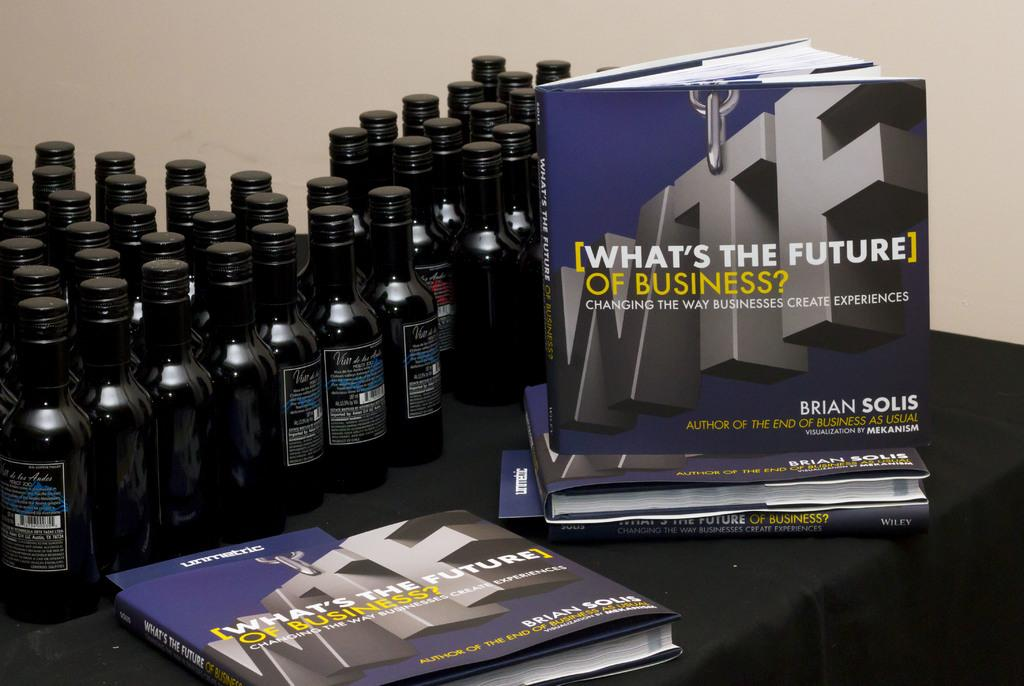<image>
Summarize the visual content of the image. Two books titled "What's the future of business?" 